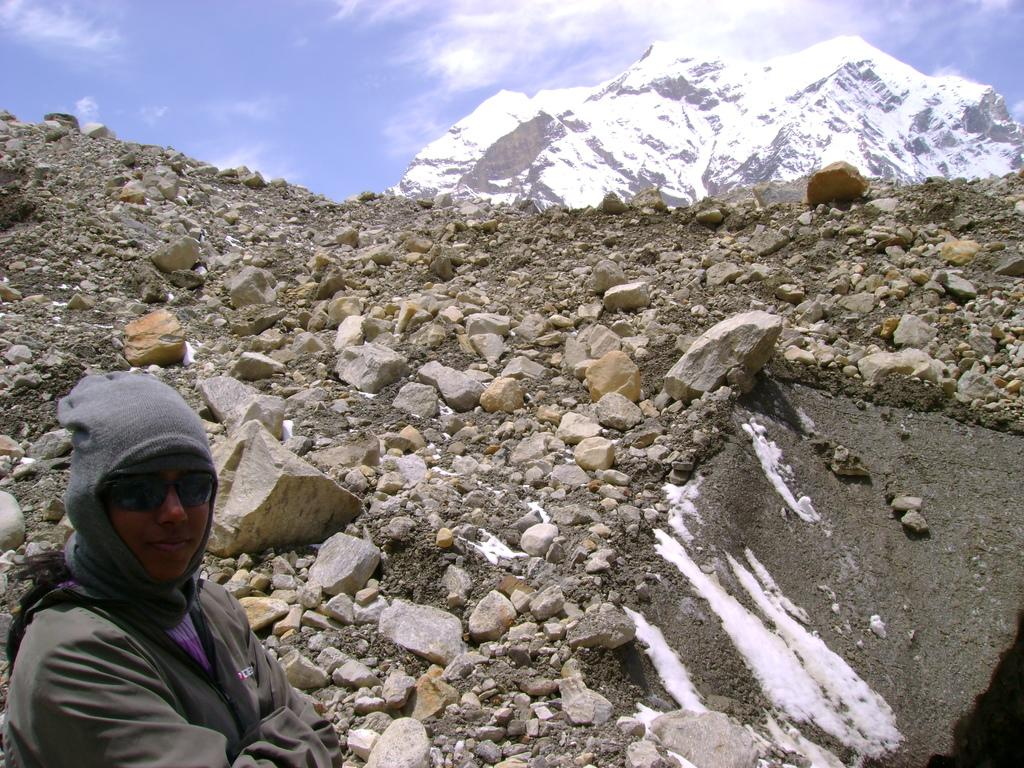Who is present in the image? There is a woman in the image. What is the woman wearing? The woman is wearing a jacket. What is the woman doing in the image? The woman is standing. What can be seen beside the woman? There are rocks beside the woman. What is visible in the background of the image? There is a mountain in the background of the image, and it is covered with snow. What type of organization is the woman affiliated with in the image? There is no information about any organization in the image; it only shows a woman standing beside rocks with a mountain in the background. 